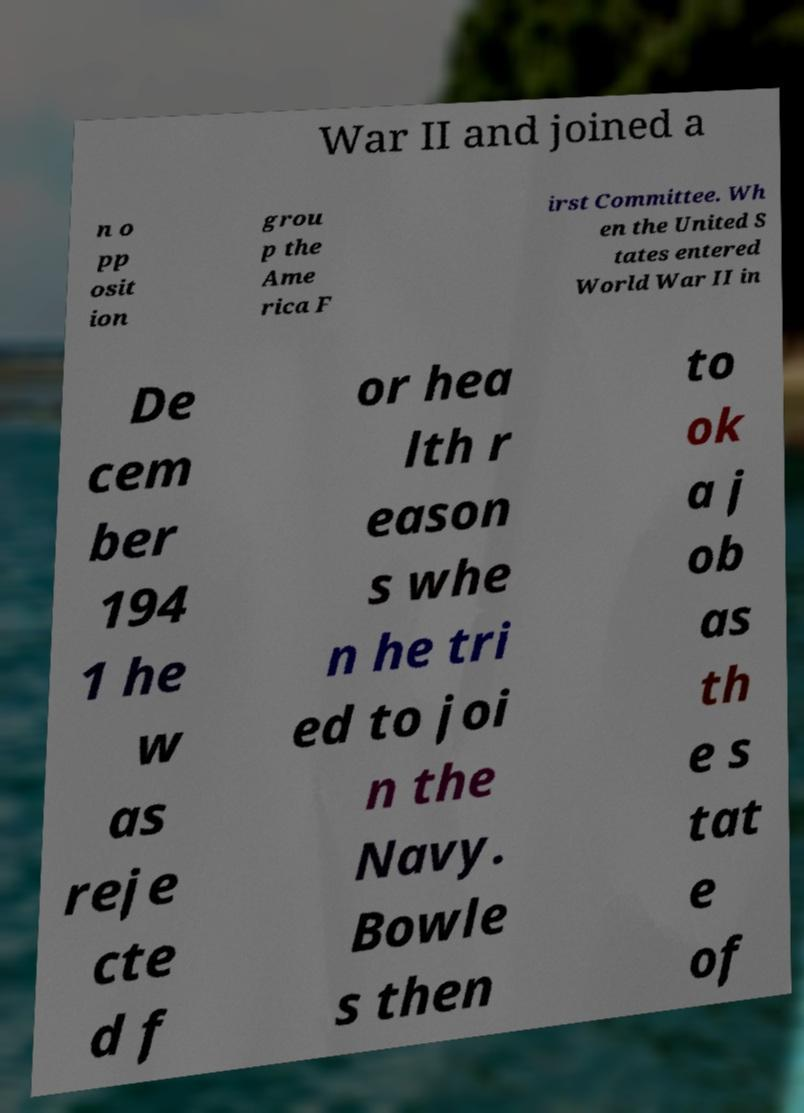Could you assist in decoding the text presented in this image and type it out clearly? War II and joined a n o pp osit ion grou p the Ame rica F irst Committee. Wh en the United S tates entered World War II in De cem ber 194 1 he w as reje cte d f or hea lth r eason s whe n he tri ed to joi n the Navy. Bowle s then to ok a j ob as th e s tat e of 